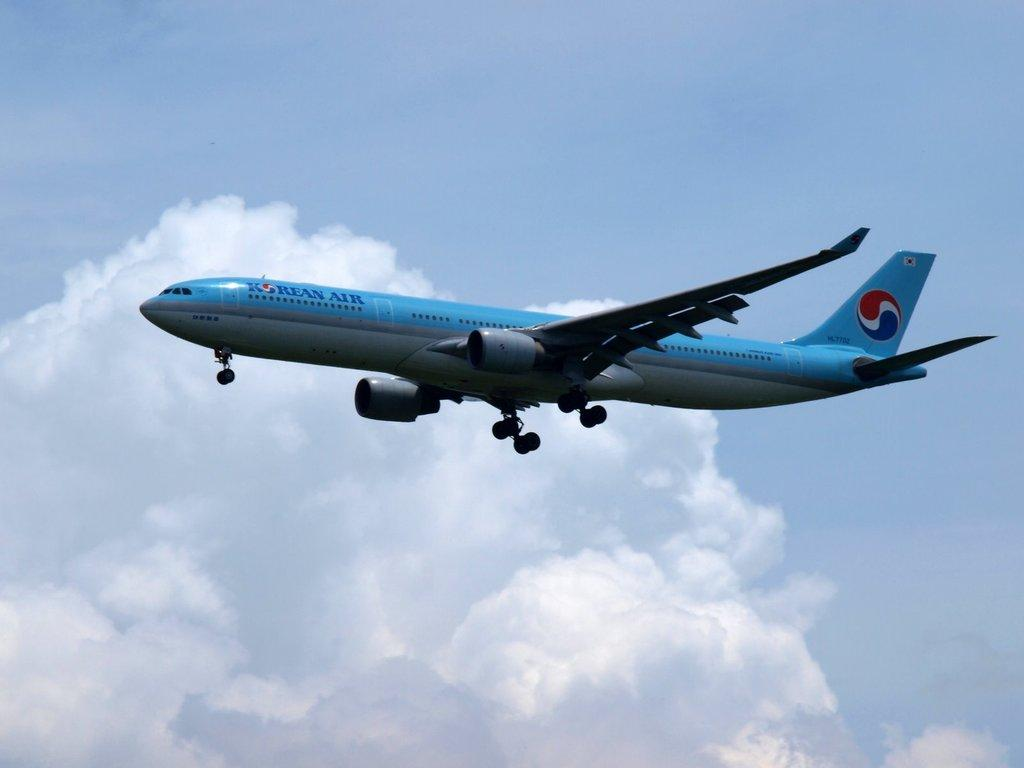<image>
Describe the image concisely. An airplane in the air reads "Korean Air" on the side. 